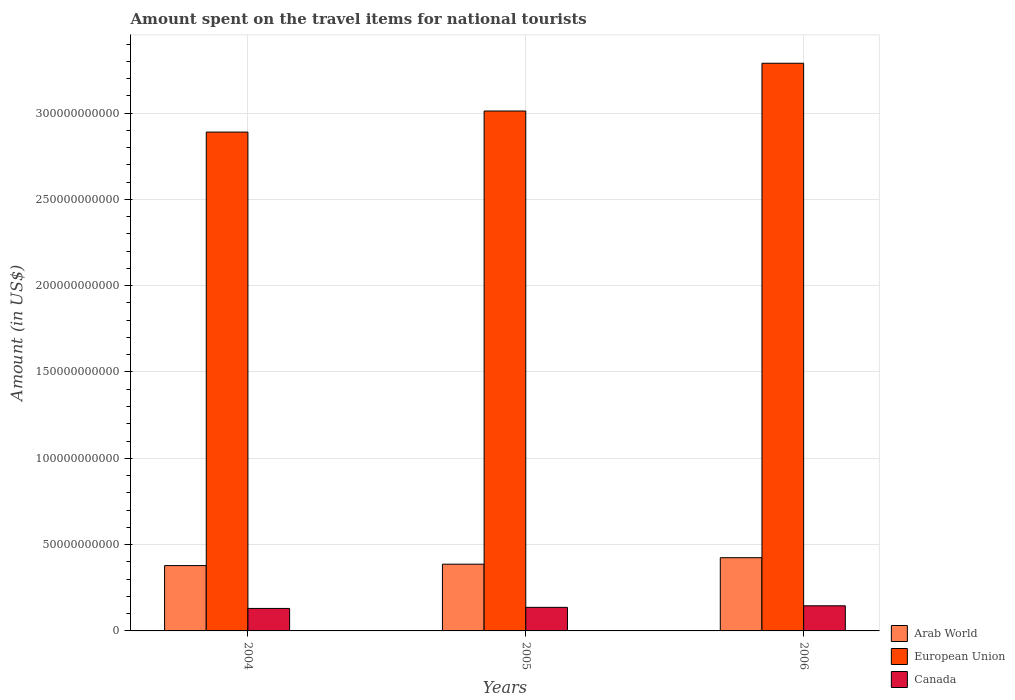How many groups of bars are there?
Provide a succinct answer. 3. Are the number of bars on each tick of the X-axis equal?
Make the answer very short. Yes. What is the amount spent on the travel items for national tourists in European Union in 2006?
Your answer should be very brief. 3.29e+11. Across all years, what is the maximum amount spent on the travel items for national tourists in Arab World?
Make the answer very short. 4.24e+1. Across all years, what is the minimum amount spent on the travel items for national tourists in Canada?
Provide a succinct answer. 1.30e+1. What is the total amount spent on the travel items for national tourists in Canada in the graph?
Provide a succinct answer. 4.12e+1. What is the difference between the amount spent on the travel items for national tourists in Arab World in 2004 and that in 2006?
Make the answer very short. -4.57e+09. What is the difference between the amount spent on the travel items for national tourists in European Union in 2006 and the amount spent on the travel items for national tourists in Arab World in 2004?
Your response must be concise. 2.91e+11. What is the average amount spent on the travel items for national tourists in Canada per year?
Give a very brief answer. 1.37e+1. In the year 2005, what is the difference between the amount spent on the travel items for national tourists in European Union and amount spent on the travel items for national tourists in Canada?
Give a very brief answer. 2.88e+11. What is the ratio of the amount spent on the travel items for national tourists in European Union in 2004 to that in 2005?
Ensure brevity in your answer.  0.96. Is the amount spent on the travel items for national tourists in European Union in 2004 less than that in 2006?
Ensure brevity in your answer.  Yes. Is the difference between the amount spent on the travel items for national tourists in European Union in 2005 and 2006 greater than the difference between the amount spent on the travel items for national tourists in Canada in 2005 and 2006?
Ensure brevity in your answer.  No. What is the difference between the highest and the second highest amount spent on the travel items for national tourists in Arab World?
Offer a terse response. 3.76e+09. What is the difference between the highest and the lowest amount spent on the travel items for national tourists in European Union?
Your answer should be very brief. 3.99e+1. In how many years, is the amount spent on the travel items for national tourists in Arab World greater than the average amount spent on the travel items for national tourists in Arab World taken over all years?
Ensure brevity in your answer.  1. Is the sum of the amount spent on the travel items for national tourists in Canada in 2004 and 2005 greater than the maximum amount spent on the travel items for national tourists in European Union across all years?
Your response must be concise. No. What does the 2nd bar from the left in 2005 represents?
Make the answer very short. European Union. What does the 1st bar from the right in 2004 represents?
Your response must be concise. Canada. How many years are there in the graph?
Provide a short and direct response. 3. Are the values on the major ticks of Y-axis written in scientific E-notation?
Ensure brevity in your answer.  No. Does the graph contain grids?
Keep it short and to the point. Yes. How many legend labels are there?
Keep it short and to the point. 3. What is the title of the graph?
Your response must be concise. Amount spent on the travel items for national tourists. Does "Peru" appear as one of the legend labels in the graph?
Your response must be concise. No. What is the Amount (in US$) of Arab World in 2004?
Offer a very short reply. 3.78e+1. What is the Amount (in US$) in European Union in 2004?
Your response must be concise. 2.89e+11. What is the Amount (in US$) in Canada in 2004?
Offer a terse response. 1.30e+1. What is the Amount (in US$) of Arab World in 2005?
Ensure brevity in your answer.  3.87e+1. What is the Amount (in US$) of European Union in 2005?
Keep it short and to the point. 3.01e+11. What is the Amount (in US$) in Canada in 2005?
Your response must be concise. 1.37e+1. What is the Amount (in US$) in Arab World in 2006?
Your answer should be compact. 4.24e+1. What is the Amount (in US$) of European Union in 2006?
Keep it short and to the point. 3.29e+11. What is the Amount (in US$) in Canada in 2006?
Provide a succinct answer. 1.46e+1. Across all years, what is the maximum Amount (in US$) in Arab World?
Keep it short and to the point. 4.24e+1. Across all years, what is the maximum Amount (in US$) of European Union?
Give a very brief answer. 3.29e+11. Across all years, what is the maximum Amount (in US$) of Canada?
Make the answer very short. 1.46e+1. Across all years, what is the minimum Amount (in US$) of Arab World?
Make the answer very short. 3.78e+1. Across all years, what is the minimum Amount (in US$) of European Union?
Offer a very short reply. 2.89e+11. Across all years, what is the minimum Amount (in US$) in Canada?
Offer a very short reply. 1.30e+1. What is the total Amount (in US$) in Arab World in the graph?
Keep it short and to the point. 1.19e+11. What is the total Amount (in US$) in European Union in the graph?
Ensure brevity in your answer.  9.19e+11. What is the total Amount (in US$) in Canada in the graph?
Ensure brevity in your answer.  4.12e+1. What is the difference between the Amount (in US$) of Arab World in 2004 and that in 2005?
Your response must be concise. -8.15e+08. What is the difference between the Amount (in US$) of European Union in 2004 and that in 2005?
Offer a terse response. -1.22e+1. What is the difference between the Amount (in US$) of Canada in 2004 and that in 2005?
Make the answer very short. -6.22e+08. What is the difference between the Amount (in US$) in Arab World in 2004 and that in 2006?
Provide a short and direct response. -4.57e+09. What is the difference between the Amount (in US$) in European Union in 2004 and that in 2006?
Make the answer very short. -3.99e+1. What is the difference between the Amount (in US$) in Canada in 2004 and that in 2006?
Make the answer very short. -1.53e+09. What is the difference between the Amount (in US$) in Arab World in 2005 and that in 2006?
Offer a very short reply. -3.76e+09. What is the difference between the Amount (in US$) of European Union in 2005 and that in 2006?
Offer a terse response. -2.77e+1. What is the difference between the Amount (in US$) of Canada in 2005 and that in 2006?
Provide a succinct answer. -9.05e+08. What is the difference between the Amount (in US$) in Arab World in 2004 and the Amount (in US$) in European Union in 2005?
Offer a terse response. -2.63e+11. What is the difference between the Amount (in US$) of Arab World in 2004 and the Amount (in US$) of Canada in 2005?
Offer a terse response. 2.42e+1. What is the difference between the Amount (in US$) of European Union in 2004 and the Amount (in US$) of Canada in 2005?
Give a very brief answer. 2.75e+11. What is the difference between the Amount (in US$) of Arab World in 2004 and the Amount (in US$) of European Union in 2006?
Give a very brief answer. -2.91e+11. What is the difference between the Amount (in US$) of Arab World in 2004 and the Amount (in US$) of Canada in 2006?
Offer a terse response. 2.33e+1. What is the difference between the Amount (in US$) in European Union in 2004 and the Amount (in US$) in Canada in 2006?
Ensure brevity in your answer.  2.74e+11. What is the difference between the Amount (in US$) in Arab World in 2005 and the Amount (in US$) in European Union in 2006?
Ensure brevity in your answer.  -2.90e+11. What is the difference between the Amount (in US$) of Arab World in 2005 and the Amount (in US$) of Canada in 2006?
Keep it short and to the point. 2.41e+1. What is the difference between the Amount (in US$) in European Union in 2005 and the Amount (in US$) in Canada in 2006?
Ensure brevity in your answer.  2.87e+11. What is the average Amount (in US$) of Arab World per year?
Your answer should be very brief. 3.96e+1. What is the average Amount (in US$) in European Union per year?
Your answer should be very brief. 3.06e+11. What is the average Amount (in US$) in Canada per year?
Provide a short and direct response. 1.37e+1. In the year 2004, what is the difference between the Amount (in US$) in Arab World and Amount (in US$) in European Union?
Your answer should be very brief. -2.51e+11. In the year 2004, what is the difference between the Amount (in US$) in Arab World and Amount (in US$) in Canada?
Keep it short and to the point. 2.48e+1. In the year 2004, what is the difference between the Amount (in US$) of European Union and Amount (in US$) of Canada?
Ensure brevity in your answer.  2.76e+11. In the year 2005, what is the difference between the Amount (in US$) in Arab World and Amount (in US$) in European Union?
Provide a short and direct response. -2.63e+11. In the year 2005, what is the difference between the Amount (in US$) in Arab World and Amount (in US$) in Canada?
Your answer should be very brief. 2.50e+1. In the year 2005, what is the difference between the Amount (in US$) of European Union and Amount (in US$) of Canada?
Ensure brevity in your answer.  2.88e+11. In the year 2006, what is the difference between the Amount (in US$) of Arab World and Amount (in US$) of European Union?
Provide a succinct answer. -2.86e+11. In the year 2006, what is the difference between the Amount (in US$) in Arab World and Amount (in US$) in Canada?
Keep it short and to the point. 2.79e+1. In the year 2006, what is the difference between the Amount (in US$) in European Union and Amount (in US$) in Canada?
Offer a very short reply. 3.14e+11. What is the ratio of the Amount (in US$) of Arab World in 2004 to that in 2005?
Make the answer very short. 0.98. What is the ratio of the Amount (in US$) in European Union in 2004 to that in 2005?
Ensure brevity in your answer.  0.96. What is the ratio of the Amount (in US$) of Canada in 2004 to that in 2005?
Your answer should be compact. 0.95. What is the ratio of the Amount (in US$) of Arab World in 2004 to that in 2006?
Make the answer very short. 0.89. What is the ratio of the Amount (in US$) in European Union in 2004 to that in 2006?
Provide a short and direct response. 0.88. What is the ratio of the Amount (in US$) in Canada in 2004 to that in 2006?
Provide a short and direct response. 0.9. What is the ratio of the Amount (in US$) of Arab World in 2005 to that in 2006?
Offer a very short reply. 0.91. What is the ratio of the Amount (in US$) in European Union in 2005 to that in 2006?
Your answer should be compact. 0.92. What is the ratio of the Amount (in US$) in Canada in 2005 to that in 2006?
Provide a succinct answer. 0.94. What is the difference between the highest and the second highest Amount (in US$) in Arab World?
Keep it short and to the point. 3.76e+09. What is the difference between the highest and the second highest Amount (in US$) in European Union?
Provide a succinct answer. 2.77e+1. What is the difference between the highest and the second highest Amount (in US$) of Canada?
Provide a short and direct response. 9.05e+08. What is the difference between the highest and the lowest Amount (in US$) in Arab World?
Provide a short and direct response. 4.57e+09. What is the difference between the highest and the lowest Amount (in US$) of European Union?
Offer a terse response. 3.99e+1. What is the difference between the highest and the lowest Amount (in US$) in Canada?
Ensure brevity in your answer.  1.53e+09. 